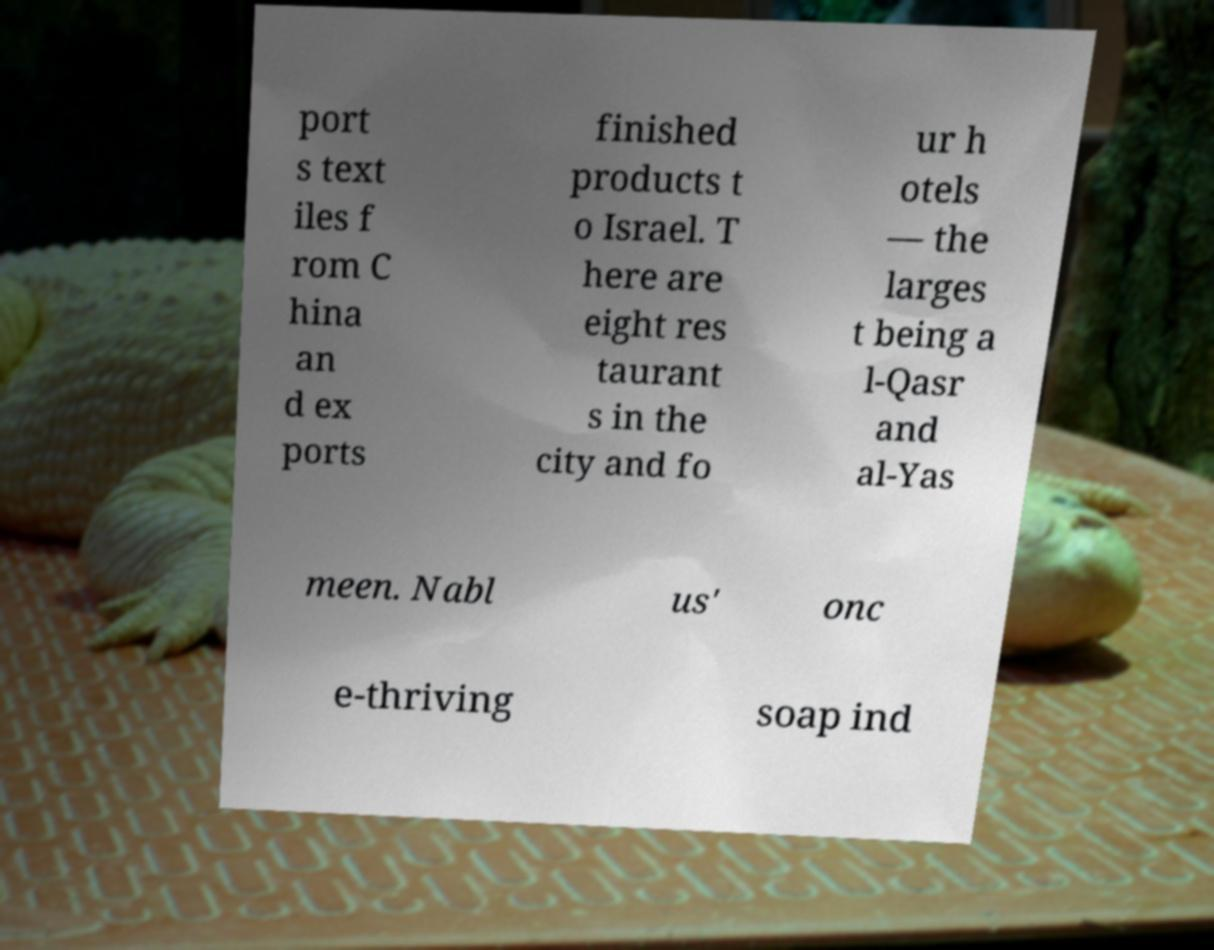Could you assist in decoding the text presented in this image and type it out clearly? port s text iles f rom C hina an d ex ports finished products t o Israel. T here are eight res taurant s in the city and fo ur h otels — the larges t being a l-Qasr and al-Yas meen. Nabl us' onc e-thriving soap ind 